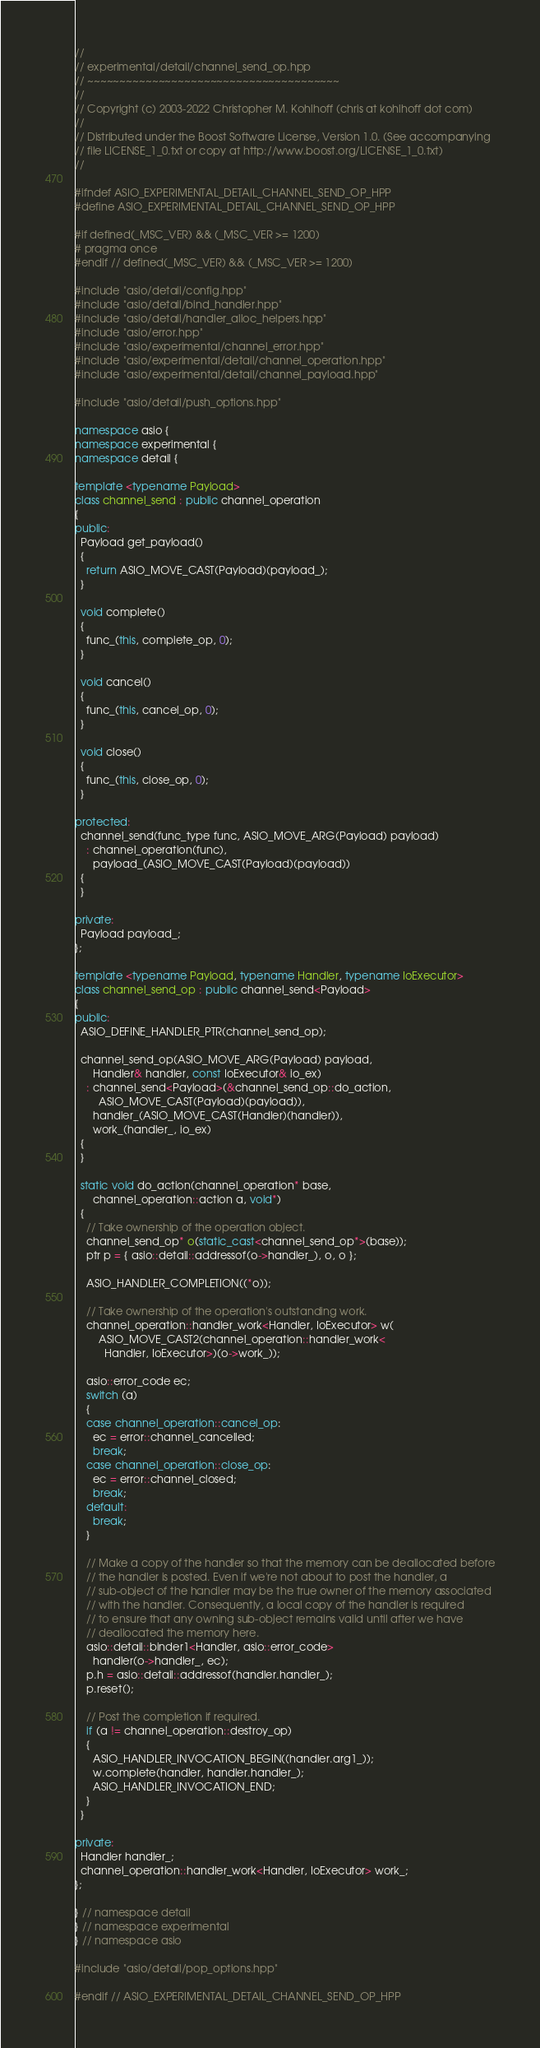<code> <loc_0><loc_0><loc_500><loc_500><_C++_>//
// experimental/detail/channel_send_op.hpp
// ~~~~~~~~~~~~~~~~~~~~~~~~~~~~~~~~~~~~~~~
//
// Copyright (c) 2003-2022 Christopher M. Kohlhoff (chris at kohlhoff dot com)
//
// Distributed under the Boost Software License, Version 1.0. (See accompanying
// file LICENSE_1_0.txt or copy at http://www.boost.org/LICENSE_1_0.txt)
//

#ifndef ASIO_EXPERIMENTAL_DETAIL_CHANNEL_SEND_OP_HPP
#define ASIO_EXPERIMENTAL_DETAIL_CHANNEL_SEND_OP_HPP

#if defined(_MSC_VER) && (_MSC_VER >= 1200)
# pragma once
#endif // defined(_MSC_VER) && (_MSC_VER >= 1200)

#include "asio/detail/config.hpp"
#include "asio/detail/bind_handler.hpp"
#include "asio/detail/handler_alloc_helpers.hpp"
#include "asio/error.hpp"
#include "asio/experimental/channel_error.hpp"
#include "asio/experimental/detail/channel_operation.hpp"
#include "asio/experimental/detail/channel_payload.hpp"

#include "asio/detail/push_options.hpp"

namespace asio {
namespace experimental {
namespace detail {

template <typename Payload>
class channel_send : public channel_operation
{
public:
  Payload get_payload()
  {
    return ASIO_MOVE_CAST(Payload)(payload_);
  }

  void complete()
  {
    func_(this, complete_op, 0);
  }

  void cancel()
  {
    func_(this, cancel_op, 0);
  }

  void close()
  {
    func_(this, close_op, 0);
  }

protected:
  channel_send(func_type func, ASIO_MOVE_ARG(Payload) payload)
    : channel_operation(func),
      payload_(ASIO_MOVE_CAST(Payload)(payload))
  {
  }

private:
  Payload payload_;
};

template <typename Payload, typename Handler, typename IoExecutor>
class channel_send_op : public channel_send<Payload>
{
public:
  ASIO_DEFINE_HANDLER_PTR(channel_send_op);

  channel_send_op(ASIO_MOVE_ARG(Payload) payload,
      Handler& handler, const IoExecutor& io_ex)
    : channel_send<Payload>(&channel_send_op::do_action,
        ASIO_MOVE_CAST(Payload)(payload)),
      handler_(ASIO_MOVE_CAST(Handler)(handler)),
      work_(handler_, io_ex)
  {
  }

  static void do_action(channel_operation* base,
      channel_operation::action a, void*)
  {
    // Take ownership of the operation object.
    channel_send_op* o(static_cast<channel_send_op*>(base));
    ptr p = { asio::detail::addressof(o->handler_), o, o };

    ASIO_HANDLER_COMPLETION((*o));

    // Take ownership of the operation's outstanding work.
    channel_operation::handler_work<Handler, IoExecutor> w(
        ASIO_MOVE_CAST2(channel_operation::handler_work<
          Handler, IoExecutor>)(o->work_));

    asio::error_code ec;
    switch (a)
    {
    case channel_operation::cancel_op:
      ec = error::channel_cancelled;
      break;
    case channel_operation::close_op:
      ec = error::channel_closed;
      break;
    default:
      break;
    }

    // Make a copy of the handler so that the memory can be deallocated before
    // the handler is posted. Even if we're not about to post the handler, a
    // sub-object of the handler may be the true owner of the memory associated
    // with the handler. Consequently, a local copy of the handler is required
    // to ensure that any owning sub-object remains valid until after we have
    // deallocated the memory here.
    asio::detail::binder1<Handler, asio::error_code>
      handler(o->handler_, ec);
    p.h = asio::detail::addressof(handler.handler_);
    p.reset();

    // Post the completion if required.
    if (a != channel_operation::destroy_op)
    {
      ASIO_HANDLER_INVOCATION_BEGIN((handler.arg1_));
      w.complete(handler, handler.handler_);
      ASIO_HANDLER_INVOCATION_END;
    }
  }

private:
  Handler handler_;
  channel_operation::handler_work<Handler, IoExecutor> work_;
};

} // namespace detail
} // namespace experimental
} // namespace asio

#include "asio/detail/pop_options.hpp"

#endif // ASIO_EXPERIMENTAL_DETAIL_CHANNEL_SEND_OP_HPP
</code> 